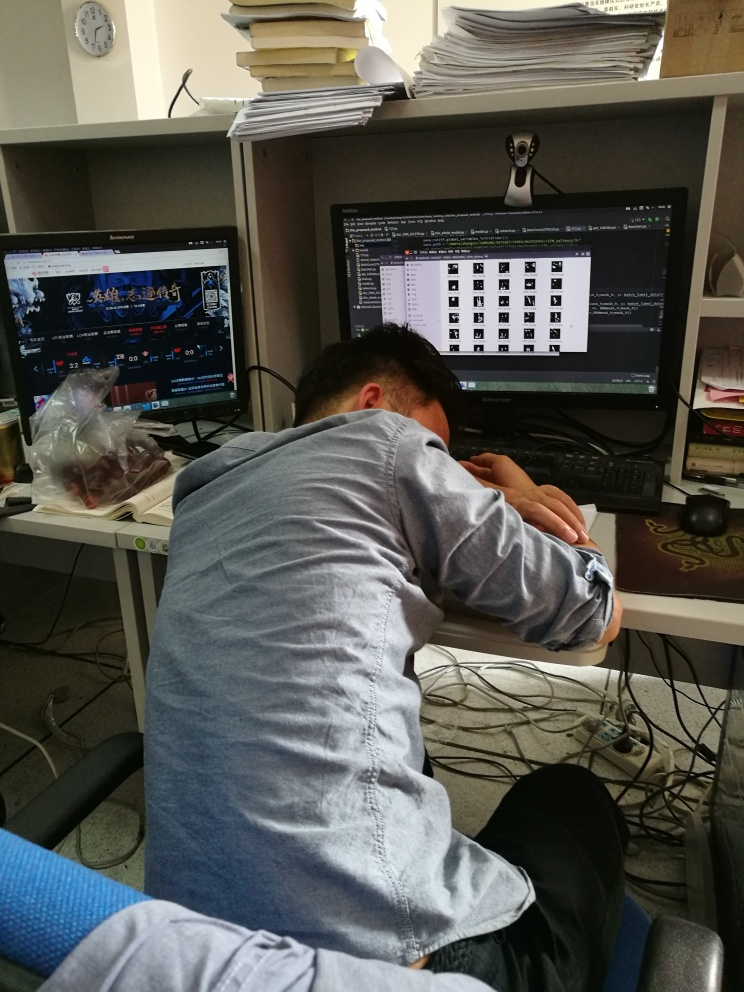Is the composition good?
A. Yes
B. No While the photo captures a candid and possibly relatable moment of someone seemingly exhausted or frustrated, possibly from work, as indicated by the cluttered desk and computer screens showing charts and a gaming website, the composition itself could be improved for a stronger visual impact. The angle is a bit too direct, and the surrounding clutter distracts from the central subject. The elements in the frame do tell a story, but with a more thought-out composition, the message could be portrayed more clearly. 